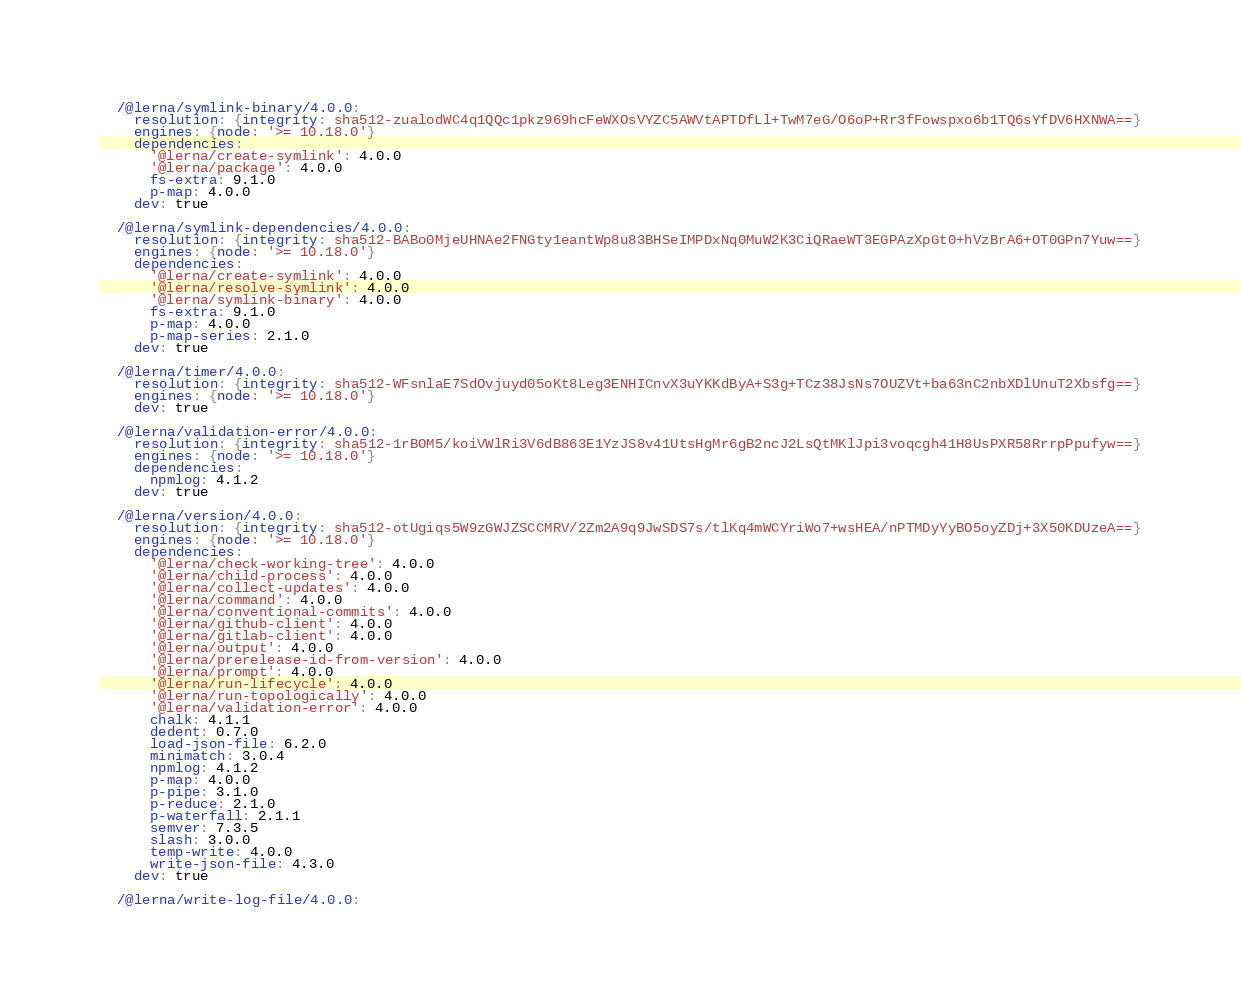Convert code to text. <code><loc_0><loc_0><loc_500><loc_500><_YAML_>
  /@lerna/symlink-binary/4.0.0:
    resolution: {integrity: sha512-zualodWC4q1QQc1pkz969hcFeWXOsVYZC5AWVtAPTDfLl+TwM7eG/O6oP+Rr3fFowspxo6b1TQ6sYfDV6HXNWA==}
    engines: {node: '>= 10.18.0'}
    dependencies:
      '@lerna/create-symlink': 4.0.0
      '@lerna/package': 4.0.0
      fs-extra: 9.1.0
      p-map: 4.0.0
    dev: true

  /@lerna/symlink-dependencies/4.0.0:
    resolution: {integrity: sha512-BABo0MjeUHNAe2FNGty1eantWp8u83BHSeIMPDxNq0MuW2K3CiQRaeWT3EGPAzXpGt0+hVzBrA6+OT0GPn7Yuw==}
    engines: {node: '>= 10.18.0'}
    dependencies:
      '@lerna/create-symlink': 4.0.0
      '@lerna/resolve-symlink': 4.0.0
      '@lerna/symlink-binary': 4.0.0
      fs-extra: 9.1.0
      p-map: 4.0.0
      p-map-series: 2.1.0
    dev: true

  /@lerna/timer/4.0.0:
    resolution: {integrity: sha512-WFsnlaE7SdOvjuyd05oKt8Leg3ENHICnvX3uYKKdByA+S3g+TCz38JsNs7OUZVt+ba63nC2nbXDlUnuT2Xbsfg==}
    engines: {node: '>= 10.18.0'}
    dev: true

  /@lerna/validation-error/4.0.0:
    resolution: {integrity: sha512-1rBOM5/koiVWlRi3V6dB863E1YzJS8v41UtsHgMr6gB2ncJ2LsQtMKlJpi3voqcgh41H8UsPXR58RrrpPpufyw==}
    engines: {node: '>= 10.18.0'}
    dependencies:
      npmlog: 4.1.2
    dev: true

  /@lerna/version/4.0.0:
    resolution: {integrity: sha512-otUgiqs5W9zGWJZSCCMRV/2Zm2A9q9JwSDS7s/tlKq4mWCYriWo7+wsHEA/nPTMDyYyBO5oyZDj+3X50KDUzeA==}
    engines: {node: '>= 10.18.0'}
    dependencies:
      '@lerna/check-working-tree': 4.0.0
      '@lerna/child-process': 4.0.0
      '@lerna/collect-updates': 4.0.0
      '@lerna/command': 4.0.0
      '@lerna/conventional-commits': 4.0.0
      '@lerna/github-client': 4.0.0
      '@lerna/gitlab-client': 4.0.0
      '@lerna/output': 4.0.0
      '@lerna/prerelease-id-from-version': 4.0.0
      '@lerna/prompt': 4.0.0
      '@lerna/run-lifecycle': 4.0.0
      '@lerna/run-topologically': 4.0.0
      '@lerna/validation-error': 4.0.0
      chalk: 4.1.1
      dedent: 0.7.0
      load-json-file: 6.2.0
      minimatch: 3.0.4
      npmlog: 4.1.2
      p-map: 4.0.0
      p-pipe: 3.1.0
      p-reduce: 2.1.0
      p-waterfall: 2.1.1
      semver: 7.3.5
      slash: 3.0.0
      temp-write: 4.0.0
      write-json-file: 4.3.0
    dev: true

  /@lerna/write-log-file/4.0.0:</code> 